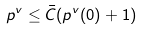Convert formula to latex. <formula><loc_0><loc_0><loc_500><loc_500>p ^ { v } \leq \bar { C } ( p ^ { v } ( 0 ) + 1 )</formula> 